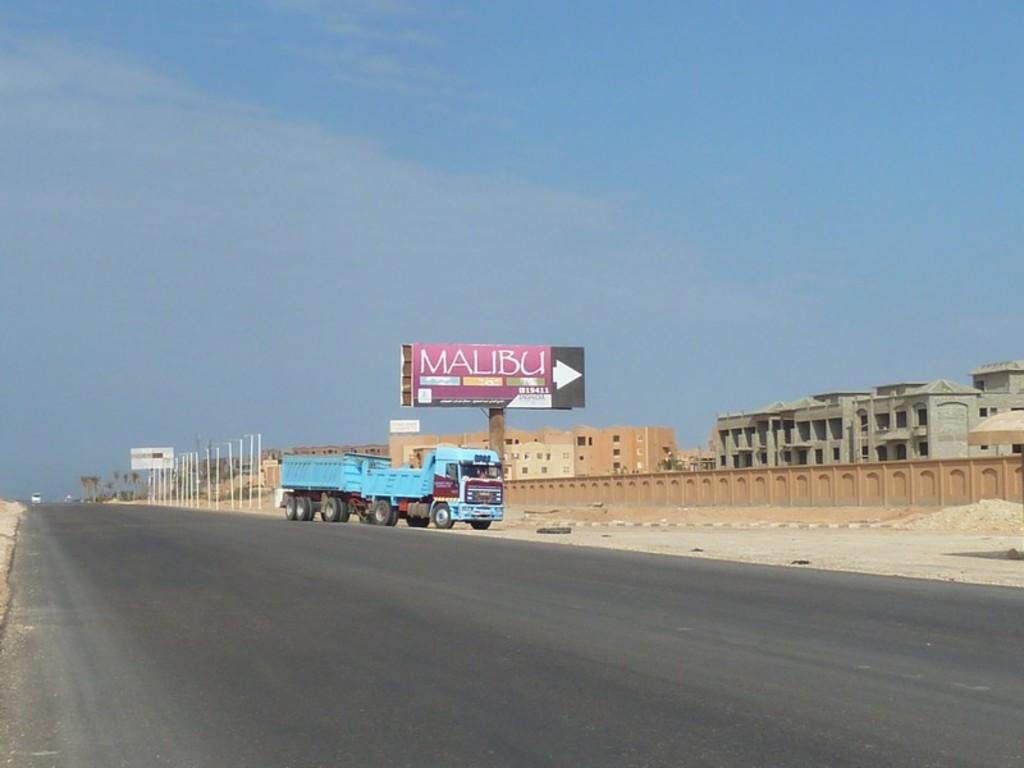<image>
Create a compact narrative representing the image presented. Pink Malubu billboard in front of some sandy buiildings. 